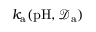Convert formula to latex. <formula><loc_0><loc_0><loc_500><loc_500>k _ { a } ( p H , \mathcal { D } _ { a } )</formula> 